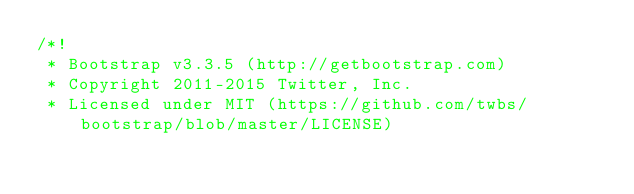<code> <loc_0><loc_0><loc_500><loc_500><_CSS_>/*!
 * Bootstrap v3.3.5 (http://getbootstrap.com)
 * Copyright 2011-2015 Twitter, Inc.
 * Licensed under MIT (https://github.com/twbs/bootstrap/blob/master/LICENSE)</code> 